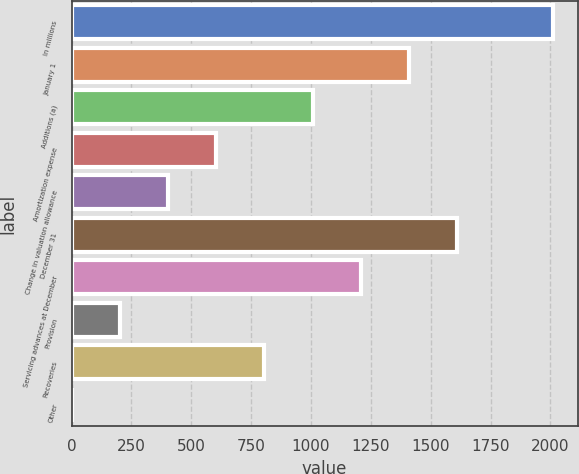<chart> <loc_0><loc_0><loc_500><loc_500><bar_chart><fcel>In millions<fcel>January 1<fcel>Additions (a)<fcel>Amortization expense<fcel>Change in valuation allowance<fcel>December 31<fcel>Servicing advances at December<fcel>Provision<fcel>Recoveries<fcel>Other<nl><fcel>2013<fcel>1409.4<fcel>1007<fcel>604.6<fcel>403.4<fcel>1610.6<fcel>1208.2<fcel>202.2<fcel>805.8<fcel>1<nl></chart> 